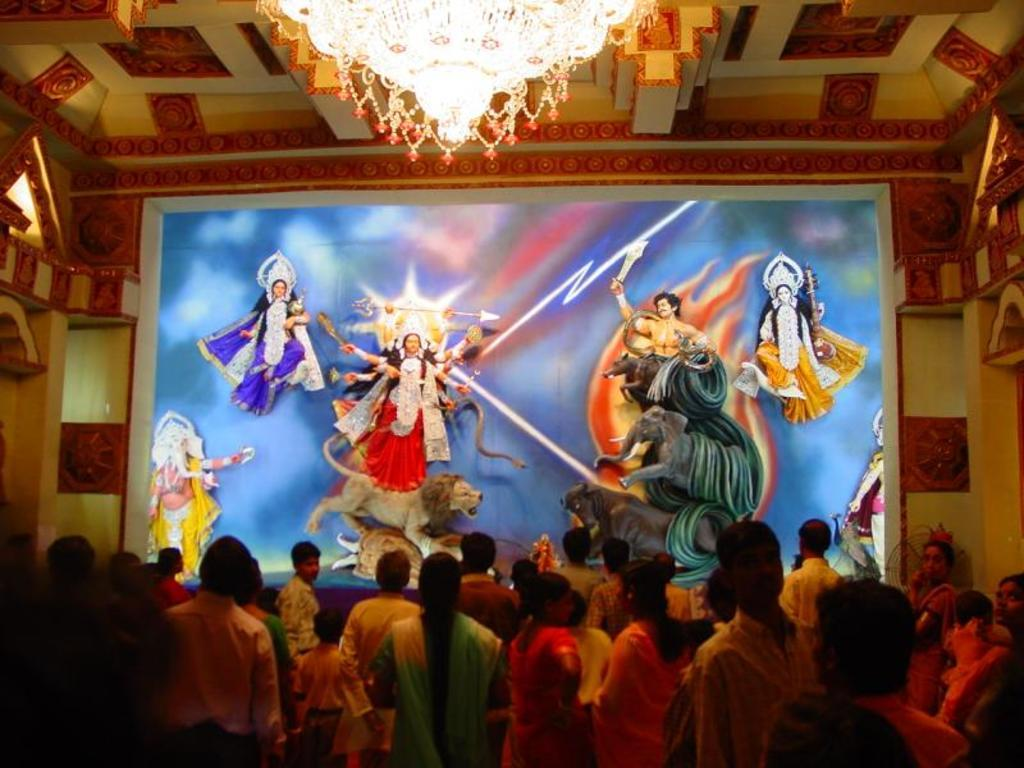What is the main object in the image? There is a screen in the image. What is shown on the screen? The screen displays goddesses. What architectural feature is visible in the image? There is a roof visible in the image. How many people are present in the image? There are many people at the bottom of the image. What type of noise can be heard coming from the goddesses on the screen? There is no sound or noise present in the image, so it cannot be determined what the goddesses might be saying or doing. 